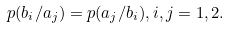Convert formula to latex. <formula><loc_0><loc_0><loc_500><loc_500>p ( b _ { i } / a _ { j } ) = p ( a _ { j } / b _ { i } ) , i , j = 1 , 2 .</formula> 